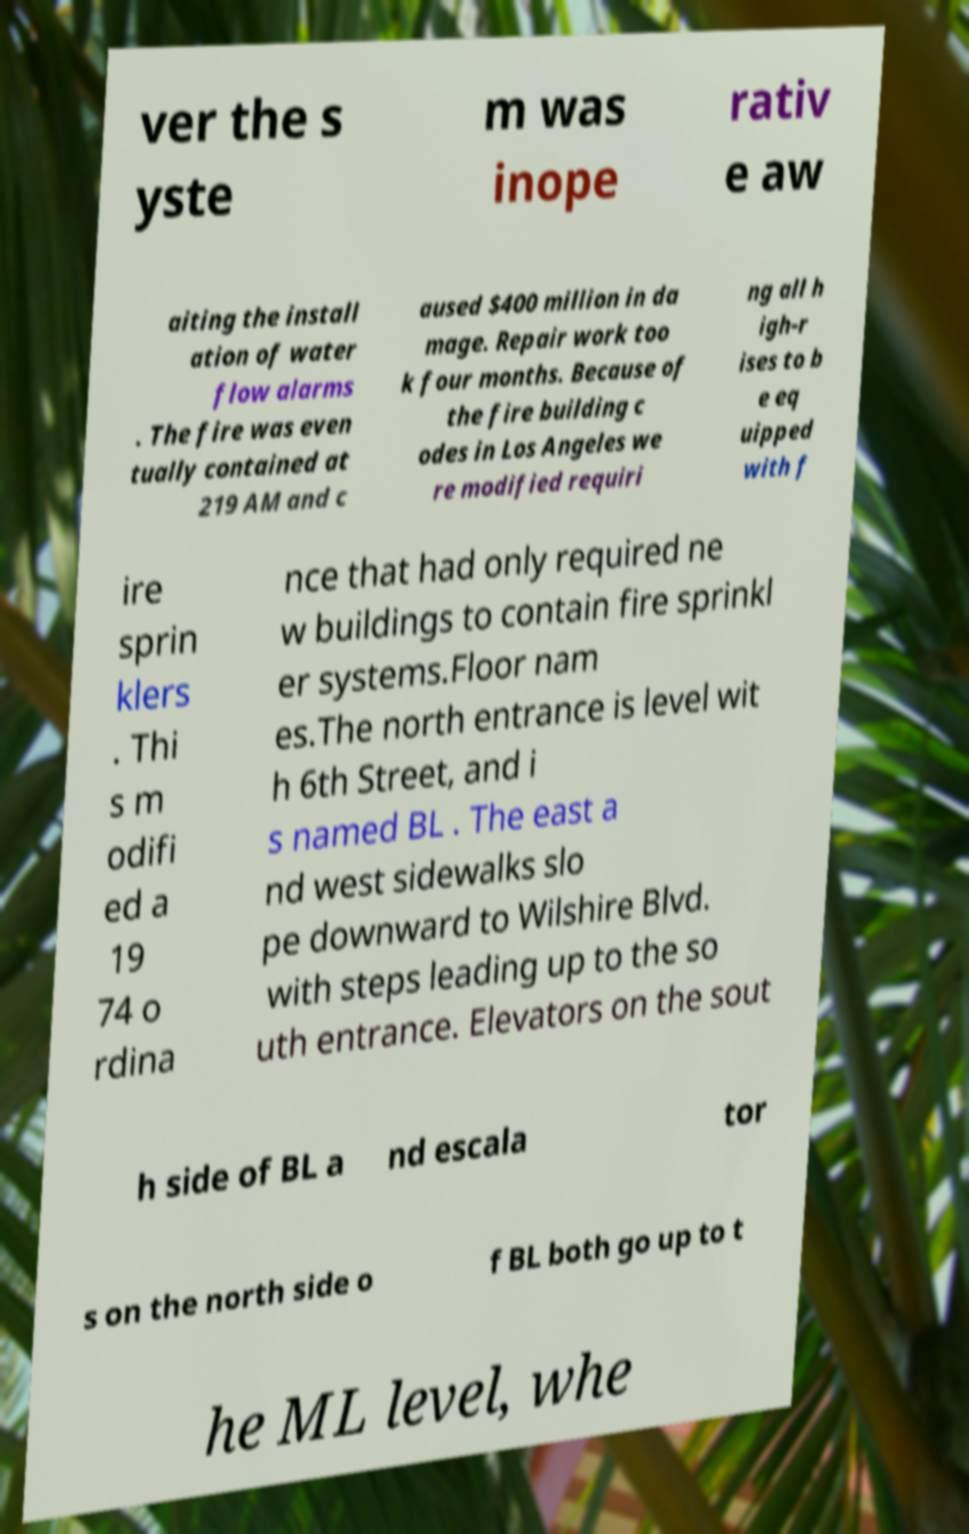Could you assist in decoding the text presented in this image and type it out clearly? ver the s yste m was inope rativ e aw aiting the install ation of water flow alarms . The fire was even tually contained at 219 AM and c aused $400 million in da mage. Repair work too k four months. Because of the fire building c odes in Los Angeles we re modified requiri ng all h igh-r ises to b e eq uipped with f ire sprin klers . Thi s m odifi ed a 19 74 o rdina nce that had only required ne w buildings to contain fire sprinkl er systems.Floor nam es.The north entrance is level wit h 6th Street, and i s named BL . The east a nd west sidewalks slo pe downward to Wilshire Blvd. with steps leading up to the so uth entrance. Elevators on the sout h side of BL a nd escala tor s on the north side o f BL both go up to t he ML level, whe 